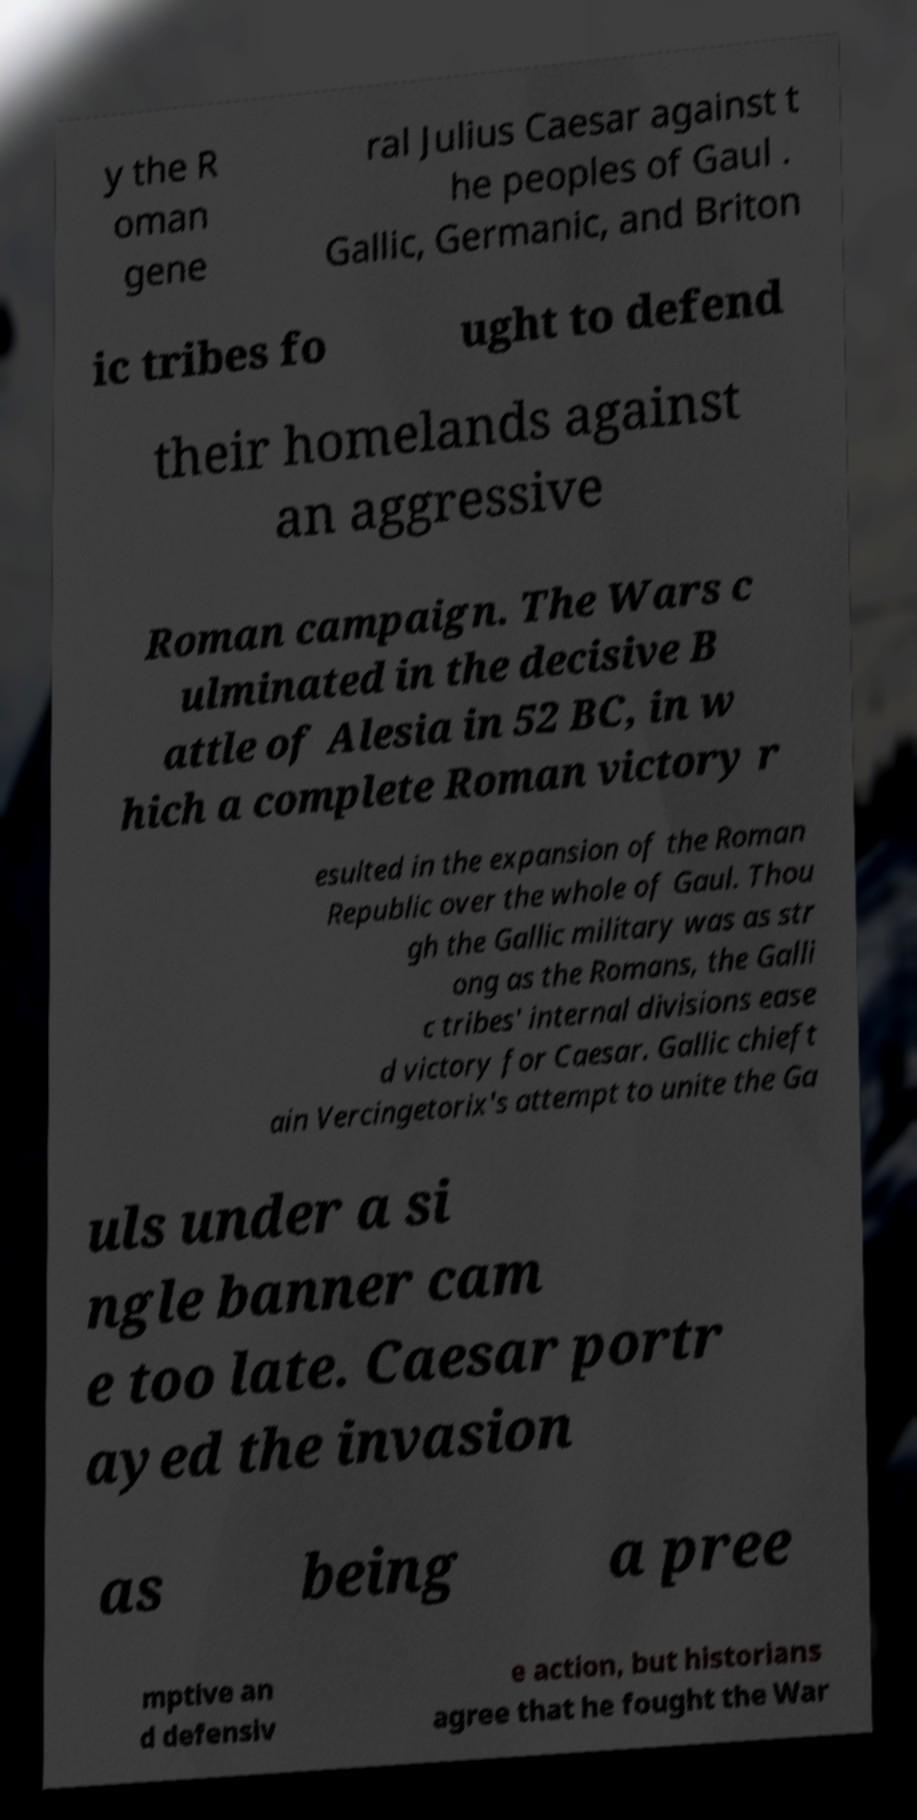There's text embedded in this image that I need extracted. Can you transcribe it verbatim? y the R oman gene ral Julius Caesar against t he peoples of Gaul . Gallic, Germanic, and Briton ic tribes fo ught to defend their homelands against an aggressive Roman campaign. The Wars c ulminated in the decisive B attle of Alesia in 52 BC, in w hich a complete Roman victory r esulted in the expansion of the Roman Republic over the whole of Gaul. Thou gh the Gallic military was as str ong as the Romans, the Galli c tribes' internal divisions ease d victory for Caesar. Gallic chieft ain Vercingetorix's attempt to unite the Ga uls under a si ngle banner cam e too late. Caesar portr ayed the invasion as being a pree mptive an d defensiv e action, but historians agree that he fought the War 